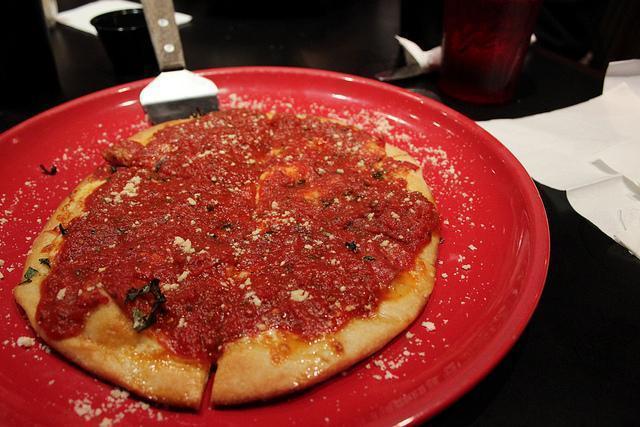What is there an excessive amount of relative to most pizzas?
Choose the correct response and explain in the format: 'Answer: answer
Rationale: rationale.'
Options: Bread, sauce, meat, vegetables. Answer: sauce.
Rationale: There is a lot of marinara sauce on the pizza. 